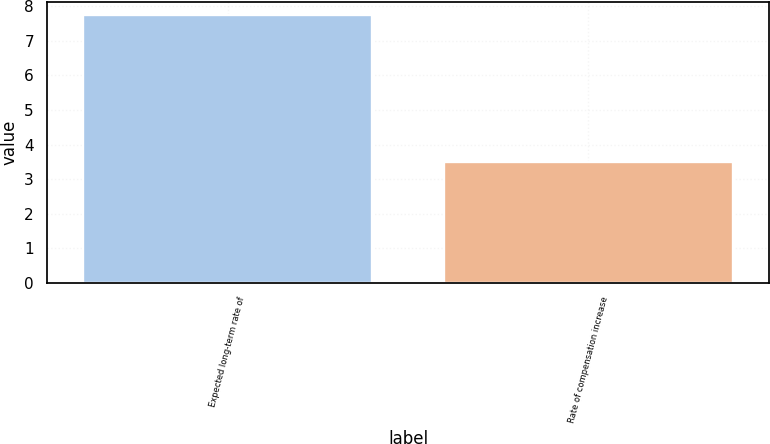<chart> <loc_0><loc_0><loc_500><loc_500><bar_chart><fcel>Expected long-term rate of<fcel>Rate of compensation increase<nl><fcel>7.75<fcel>3.5<nl></chart> 